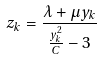<formula> <loc_0><loc_0><loc_500><loc_500>z _ { k } = \frac { \lambda + \mu y _ { k } } { \frac { y _ { k } ^ { 2 } } { C } - 3 }</formula> 